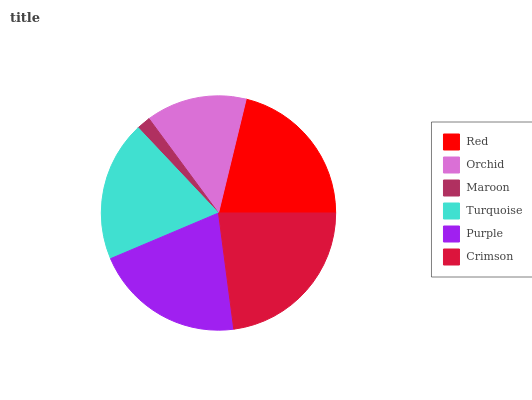Is Maroon the minimum?
Answer yes or no. Yes. Is Crimson the maximum?
Answer yes or no. Yes. Is Orchid the minimum?
Answer yes or no. No. Is Orchid the maximum?
Answer yes or no. No. Is Red greater than Orchid?
Answer yes or no. Yes. Is Orchid less than Red?
Answer yes or no. Yes. Is Orchid greater than Red?
Answer yes or no. No. Is Red less than Orchid?
Answer yes or no. No. Is Purple the high median?
Answer yes or no. Yes. Is Turquoise the low median?
Answer yes or no. Yes. Is Crimson the high median?
Answer yes or no. No. Is Orchid the low median?
Answer yes or no. No. 